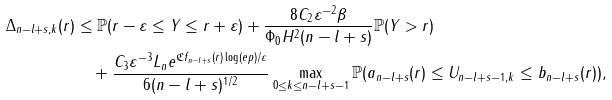<formula> <loc_0><loc_0><loc_500><loc_500>\Delta _ { n - l + s , k } ( r ) & \leq \mathbb { P } ( r - \varepsilon \leq \| Y \| \leq r + \varepsilon ) + \frac { 8 C _ { 2 } \varepsilon ^ { - 2 } \beta } { \Phi _ { 0 } H ^ { 2 } ( n - l + s ) } \mathbb { P } ( \| Y \| > r ) \\ & \quad + \frac { C _ { 3 } \varepsilon ^ { - 3 } L _ { n } e ^ { \mathfrak { C } f _ { n - l + s } ( r ) \log ( e p ) / \varepsilon } } { 6 ( n - l + s ) ^ { 1 / 2 } } \max _ { 0 \leq k \leq n - l + s - 1 } \mathbb { P } ( a _ { n - l + s } ( r ) \leq \| U _ { n - l + s - 1 , k } \| \leq b _ { n - l + s } ( r ) ) ,</formula> 